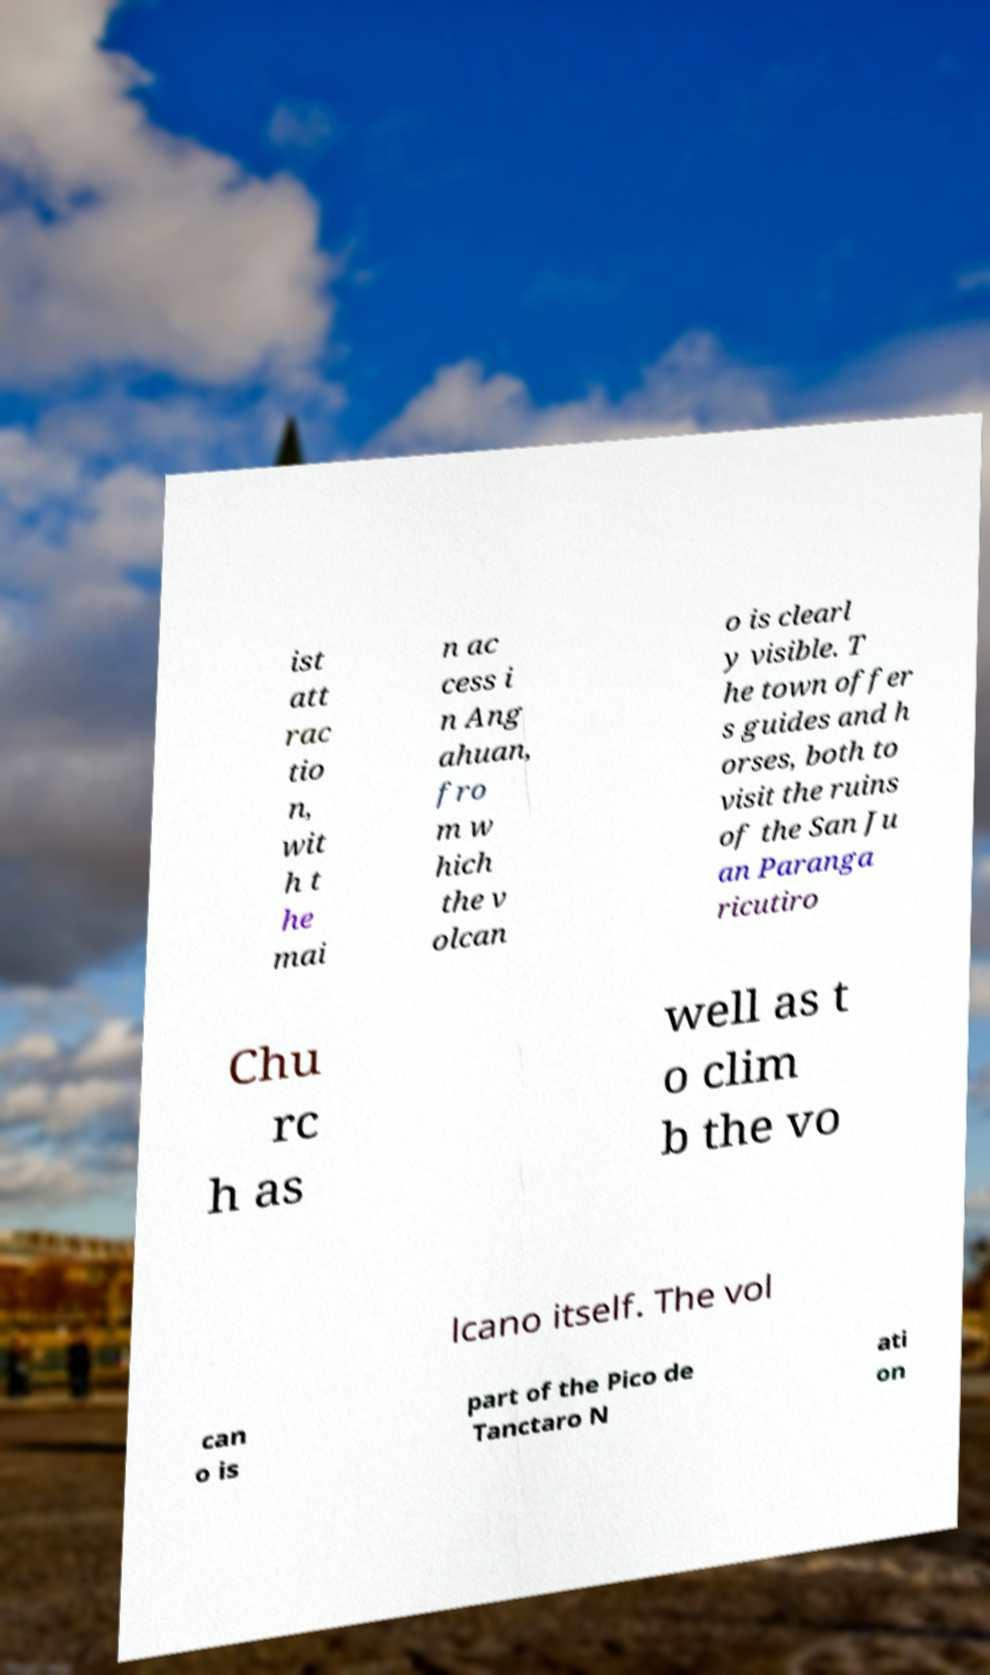Can you accurately transcribe the text from the provided image for me? ist att rac tio n, wit h t he mai n ac cess i n Ang ahuan, fro m w hich the v olcan o is clearl y visible. T he town offer s guides and h orses, both to visit the ruins of the San Ju an Paranga ricutiro Chu rc h as well as t o clim b the vo lcano itself. The vol can o is part of the Pico de Tanctaro N ati on 